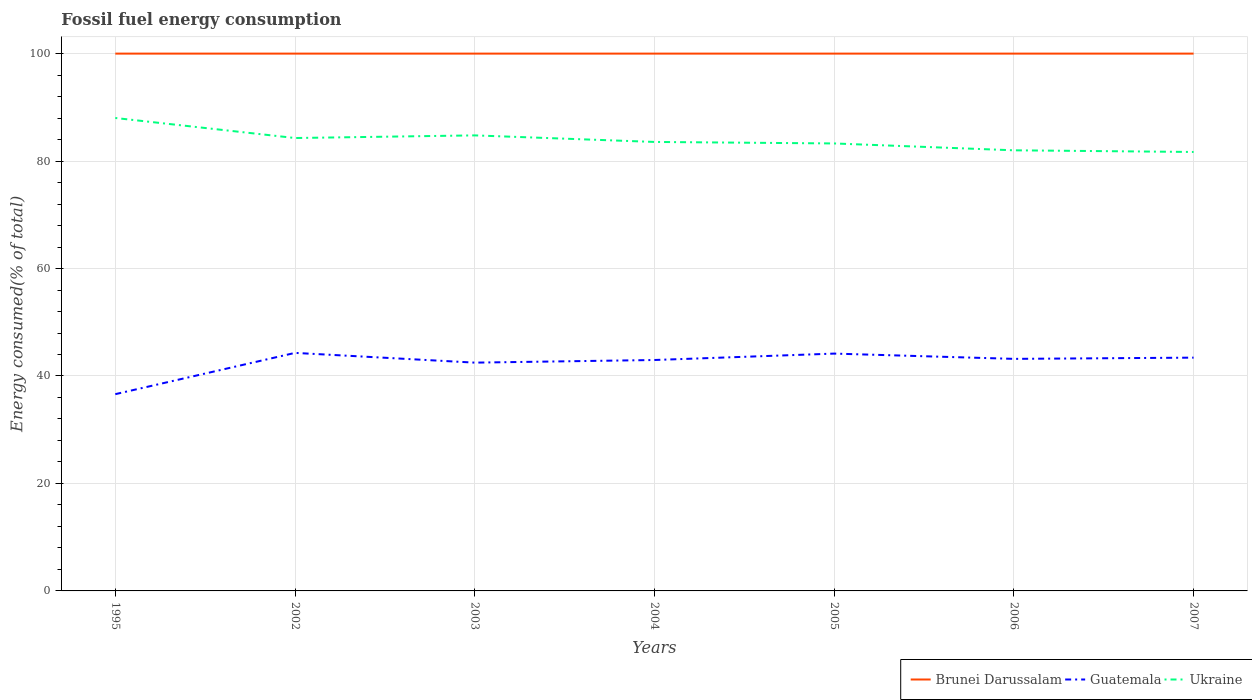How many different coloured lines are there?
Give a very brief answer. 3. Does the line corresponding to Ukraine intersect with the line corresponding to Guatemala?
Provide a short and direct response. No. Is the number of lines equal to the number of legend labels?
Make the answer very short. Yes. Across all years, what is the maximum percentage of energy consumed in Brunei Darussalam?
Your answer should be very brief. 100. In which year was the percentage of energy consumed in Guatemala maximum?
Offer a terse response. 1995. What is the total percentage of energy consumed in Guatemala in the graph?
Your response must be concise. -1.68. What is the difference between the highest and the second highest percentage of energy consumed in Ukraine?
Make the answer very short. 6.33. Is the percentage of energy consumed in Brunei Darussalam strictly greater than the percentage of energy consumed in Ukraine over the years?
Your response must be concise. No. Does the graph contain any zero values?
Your answer should be compact. No. Does the graph contain grids?
Offer a terse response. Yes. What is the title of the graph?
Your answer should be very brief. Fossil fuel energy consumption. Does "Colombia" appear as one of the legend labels in the graph?
Give a very brief answer. No. What is the label or title of the X-axis?
Provide a succinct answer. Years. What is the label or title of the Y-axis?
Provide a succinct answer. Energy consumed(% of total). What is the Energy consumed(% of total) of Guatemala in 1995?
Give a very brief answer. 36.62. What is the Energy consumed(% of total) in Ukraine in 1995?
Your answer should be compact. 88.02. What is the Energy consumed(% of total) of Brunei Darussalam in 2002?
Ensure brevity in your answer.  100. What is the Energy consumed(% of total) in Guatemala in 2002?
Keep it short and to the point. 44.3. What is the Energy consumed(% of total) of Ukraine in 2002?
Your answer should be compact. 84.29. What is the Energy consumed(% of total) in Brunei Darussalam in 2003?
Provide a succinct answer. 100. What is the Energy consumed(% of total) of Guatemala in 2003?
Make the answer very short. 42.49. What is the Energy consumed(% of total) in Ukraine in 2003?
Keep it short and to the point. 84.78. What is the Energy consumed(% of total) of Guatemala in 2004?
Offer a very short reply. 42.98. What is the Energy consumed(% of total) in Ukraine in 2004?
Your response must be concise. 83.56. What is the Energy consumed(% of total) of Brunei Darussalam in 2005?
Make the answer very short. 100. What is the Energy consumed(% of total) of Guatemala in 2005?
Offer a very short reply. 44.17. What is the Energy consumed(% of total) of Ukraine in 2005?
Your answer should be very brief. 83.28. What is the Energy consumed(% of total) of Guatemala in 2006?
Keep it short and to the point. 43.19. What is the Energy consumed(% of total) in Ukraine in 2006?
Provide a succinct answer. 82. What is the Energy consumed(% of total) in Brunei Darussalam in 2007?
Your answer should be compact. 100. What is the Energy consumed(% of total) in Guatemala in 2007?
Give a very brief answer. 43.42. What is the Energy consumed(% of total) of Ukraine in 2007?
Provide a succinct answer. 81.69. Across all years, what is the maximum Energy consumed(% of total) of Guatemala?
Provide a short and direct response. 44.3. Across all years, what is the maximum Energy consumed(% of total) in Ukraine?
Offer a terse response. 88.02. Across all years, what is the minimum Energy consumed(% of total) of Brunei Darussalam?
Your answer should be very brief. 100. Across all years, what is the minimum Energy consumed(% of total) in Guatemala?
Give a very brief answer. 36.62. Across all years, what is the minimum Energy consumed(% of total) of Ukraine?
Make the answer very short. 81.69. What is the total Energy consumed(% of total) in Brunei Darussalam in the graph?
Give a very brief answer. 700. What is the total Energy consumed(% of total) in Guatemala in the graph?
Keep it short and to the point. 297.15. What is the total Energy consumed(% of total) in Ukraine in the graph?
Provide a short and direct response. 587.62. What is the difference between the Energy consumed(% of total) of Brunei Darussalam in 1995 and that in 2002?
Keep it short and to the point. 0. What is the difference between the Energy consumed(% of total) of Guatemala in 1995 and that in 2002?
Ensure brevity in your answer.  -7.68. What is the difference between the Energy consumed(% of total) in Ukraine in 1995 and that in 2002?
Give a very brief answer. 3.73. What is the difference between the Energy consumed(% of total) in Brunei Darussalam in 1995 and that in 2003?
Your answer should be compact. 0. What is the difference between the Energy consumed(% of total) of Guatemala in 1995 and that in 2003?
Your answer should be compact. -5.87. What is the difference between the Energy consumed(% of total) in Ukraine in 1995 and that in 2003?
Give a very brief answer. 3.24. What is the difference between the Energy consumed(% of total) in Guatemala in 1995 and that in 2004?
Offer a terse response. -6.36. What is the difference between the Energy consumed(% of total) in Ukraine in 1995 and that in 2004?
Your answer should be compact. 4.46. What is the difference between the Energy consumed(% of total) of Guatemala in 1995 and that in 2005?
Your response must be concise. -7.55. What is the difference between the Energy consumed(% of total) in Ukraine in 1995 and that in 2005?
Offer a very short reply. 4.74. What is the difference between the Energy consumed(% of total) in Brunei Darussalam in 1995 and that in 2006?
Provide a succinct answer. 0. What is the difference between the Energy consumed(% of total) in Guatemala in 1995 and that in 2006?
Give a very brief answer. -6.57. What is the difference between the Energy consumed(% of total) in Ukraine in 1995 and that in 2006?
Make the answer very short. 6.02. What is the difference between the Energy consumed(% of total) of Brunei Darussalam in 1995 and that in 2007?
Provide a short and direct response. 0. What is the difference between the Energy consumed(% of total) in Guatemala in 1995 and that in 2007?
Ensure brevity in your answer.  -6.8. What is the difference between the Energy consumed(% of total) in Ukraine in 1995 and that in 2007?
Your response must be concise. 6.33. What is the difference between the Energy consumed(% of total) of Brunei Darussalam in 2002 and that in 2003?
Your answer should be very brief. -0. What is the difference between the Energy consumed(% of total) in Guatemala in 2002 and that in 2003?
Your answer should be very brief. 1.81. What is the difference between the Energy consumed(% of total) in Ukraine in 2002 and that in 2003?
Your answer should be compact. -0.49. What is the difference between the Energy consumed(% of total) of Brunei Darussalam in 2002 and that in 2004?
Make the answer very short. -0. What is the difference between the Energy consumed(% of total) in Guatemala in 2002 and that in 2004?
Provide a short and direct response. 1.33. What is the difference between the Energy consumed(% of total) in Ukraine in 2002 and that in 2004?
Provide a short and direct response. 0.73. What is the difference between the Energy consumed(% of total) of Brunei Darussalam in 2002 and that in 2005?
Your answer should be compact. -0. What is the difference between the Energy consumed(% of total) of Guatemala in 2002 and that in 2005?
Provide a short and direct response. 0.13. What is the difference between the Energy consumed(% of total) of Ukraine in 2002 and that in 2005?
Your answer should be very brief. 1.01. What is the difference between the Energy consumed(% of total) of Brunei Darussalam in 2002 and that in 2006?
Make the answer very short. -0. What is the difference between the Energy consumed(% of total) in Guatemala in 2002 and that in 2006?
Provide a short and direct response. 1.11. What is the difference between the Energy consumed(% of total) in Ukraine in 2002 and that in 2006?
Your answer should be compact. 2.29. What is the difference between the Energy consumed(% of total) in Brunei Darussalam in 2002 and that in 2007?
Your response must be concise. -0. What is the difference between the Energy consumed(% of total) in Guatemala in 2002 and that in 2007?
Your answer should be compact. 0.89. What is the difference between the Energy consumed(% of total) in Ukraine in 2002 and that in 2007?
Your response must be concise. 2.6. What is the difference between the Energy consumed(% of total) of Brunei Darussalam in 2003 and that in 2004?
Your answer should be very brief. 0. What is the difference between the Energy consumed(% of total) of Guatemala in 2003 and that in 2004?
Offer a very short reply. -0.49. What is the difference between the Energy consumed(% of total) of Ukraine in 2003 and that in 2004?
Offer a terse response. 1.22. What is the difference between the Energy consumed(% of total) of Brunei Darussalam in 2003 and that in 2005?
Your answer should be compact. 0. What is the difference between the Energy consumed(% of total) in Guatemala in 2003 and that in 2005?
Offer a terse response. -1.68. What is the difference between the Energy consumed(% of total) of Ukraine in 2003 and that in 2005?
Offer a terse response. 1.5. What is the difference between the Energy consumed(% of total) of Guatemala in 2003 and that in 2006?
Provide a succinct answer. -0.7. What is the difference between the Energy consumed(% of total) in Ukraine in 2003 and that in 2006?
Your answer should be very brief. 2.78. What is the difference between the Energy consumed(% of total) in Brunei Darussalam in 2003 and that in 2007?
Your answer should be compact. 0. What is the difference between the Energy consumed(% of total) of Guatemala in 2003 and that in 2007?
Make the answer very short. -0.93. What is the difference between the Energy consumed(% of total) of Ukraine in 2003 and that in 2007?
Your answer should be very brief. 3.09. What is the difference between the Energy consumed(% of total) of Brunei Darussalam in 2004 and that in 2005?
Your answer should be very brief. 0. What is the difference between the Energy consumed(% of total) in Guatemala in 2004 and that in 2005?
Provide a short and direct response. -1.19. What is the difference between the Energy consumed(% of total) of Ukraine in 2004 and that in 2005?
Give a very brief answer. 0.28. What is the difference between the Energy consumed(% of total) in Brunei Darussalam in 2004 and that in 2006?
Offer a terse response. 0. What is the difference between the Energy consumed(% of total) of Guatemala in 2004 and that in 2006?
Provide a succinct answer. -0.21. What is the difference between the Energy consumed(% of total) of Ukraine in 2004 and that in 2006?
Make the answer very short. 1.56. What is the difference between the Energy consumed(% of total) of Brunei Darussalam in 2004 and that in 2007?
Your answer should be compact. 0. What is the difference between the Energy consumed(% of total) of Guatemala in 2004 and that in 2007?
Give a very brief answer. -0.44. What is the difference between the Energy consumed(% of total) in Ukraine in 2004 and that in 2007?
Make the answer very short. 1.87. What is the difference between the Energy consumed(% of total) of Brunei Darussalam in 2005 and that in 2006?
Offer a very short reply. 0. What is the difference between the Energy consumed(% of total) of Guatemala in 2005 and that in 2006?
Give a very brief answer. 0.98. What is the difference between the Energy consumed(% of total) in Ukraine in 2005 and that in 2006?
Give a very brief answer. 1.28. What is the difference between the Energy consumed(% of total) of Brunei Darussalam in 2005 and that in 2007?
Offer a very short reply. 0. What is the difference between the Energy consumed(% of total) in Guatemala in 2005 and that in 2007?
Give a very brief answer. 0.75. What is the difference between the Energy consumed(% of total) of Ukraine in 2005 and that in 2007?
Offer a very short reply. 1.59. What is the difference between the Energy consumed(% of total) of Brunei Darussalam in 2006 and that in 2007?
Your answer should be compact. 0. What is the difference between the Energy consumed(% of total) of Guatemala in 2006 and that in 2007?
Keep it short and to the point. -0.23. What is the difference between the Energy consumed(% of total) of Ukraine in 2006 and that in 2007?
Offer a very short reply. 0.31. What is the difference between the Energy consumed(% of total) in Brunei Darussalam in 1995 and the Energy consumed(% of total) in Guatemala in 2002?
Offer a very short reply. 55.7. What is the difference between the Energy consumed(% of total) in Brunei Darussalam in 1995 and the Energy consumed(% of total) in Ukraine in 2002?
Ensure brevity in your answer.  15.71. What is the difference between the Energy consumed(% of total) of Guatemala in 1995 and the Energy consumed(% of total) of Ukraine in 2002?
Your response must be concise. -47.67. What is the difference between the Energy consumed(% of total) in Brunei Darussalam in 1995 and the Energy consumed(% of total) in Guatemala in 2003?
Offer a very short reply. 57.51. What is the difference between the Energy consumed(% of total) of Brunei Darussalam in 1995 and the Energy consumed(% of total) of Ukraine in 2003?
Your answer should be compact. 15.22. What is the difference between the Energy consumed(% of total) in Guatemala in 1995 and the Energy consumed(% of total) in Ukraine in 2003?
Your answer should be very brief. -48.16. What is the difference between the Energy consumed(% of total) of Brunei Darussalam in 1995 and the Energy consumed(% of total) of Guatemala in 2004?
Give a very brief answer. 57.02. What is the difference between the Energy consumed(% of total) in Brunei Darussalam in 1995 and the Energy consumed(% of total) in Ukraine in 2004?
Give a very brief answer. 16.44. What is the difference between the Energy consumed(% of total) in Guatemala in 1995 and the Energy consumed(% of total) in Ukraine in 2004?
Provide a short and direct response. -46.94. What is the difference between the Energy consumed(% of total) of Brunei Darussalam in 1995 and the Energy consumed(% of total) of Guatemala in 2005?
Your response must be concise. 55.83. What is the difference between the Energy consumed(% of total) of Brunei Darussalam in 1995 and the Energy consumed(% of total) of Ukraine in 2005?
Provide a short and direct response. 16.72. What is the difference between the Energy consumed(% of total) in Guatemala in 1995 and the Energy consumed(% of total) in Ukraine in 2005?
Offer a terse response. -46.66. What is the difference between the Energy consumed(% of total) in Brunei Darussalam in 1995 and the Energy consumed(% of total) in Guatemala in 2006?
Make the answer very short. 56.81. What is the difference between the Energy consumed(% of total) in Brunei Darussalam in 1995 and the Energy consumed(% of total) in Ukraine in 2006?
Offer a terse response. 18. What is the difference between the Energy consumed(% of total) in Guatemala in 1995 and the Energy consumed(% of total) in Ukraine in 2006?
Make the answer very short. -45.38. What is the difference between the Energy consumed(% of total) of Brunei Darussalam in 1995 and the Energy consumed(% of total) of Guatemala in 2007?
Offer a terse response. 56.58. What is the difference between the Energy consumed(% of total) of Brunei Darussalam in 1995 and the Energy consumed(% of total) of Ukraine in 2007?
Ensure brevity in your answer.  18.31. What is the difference between the Energy consumed(% of total) of Guatemala in 1995 and the Energy consumed(% of total) of Ukraine in 2007?
Give a very brief answer. -45.07. What is the difference between the Energy consumed(% of total) in Brunei Darussalam in 2002 and the Energy consumed(% of total) in Guatemala in 2003?
Provide a short and direct response. 57.51. What is the difference between the Energy consumed(% of total) in Brunei Darussalam in 2002 and the Energy consumed(% of total) in Ukraine in 2003?
Your answer should be very brief. 15.22. What is the difference between the Energy consumed(% of total) of Guatemala in 2002 and the Energy consumed(% of total) of Ukraine in 2003?
Keep it short and to the point. -40.48. What is the difference between the Energy consumed(% of total) of Brunei Darussalam in 2002 and the Energy consumed(% of total) of Guatemala in 2004?
Provide a succinct answer. 57.02. What is the difference between the Energy consumed(% of total) of Brunei Darussalam in 2002 and the Energy consumed(% of total) of Ukraine in 2004?
Your answer should be compact. 16.44. What is the difference between the Energy consumed(% of total) of Guatemala in 2002 and the Energy consumed(% of total) of Ukraine in 2004?
Your answer should be very brief. -39.26. What is the difference between the Energy consumed(% of total) in Brunei Darussalam in 2002 and the Energy consumed(% of total) in Guatemala in 2005?
Your response must be concise. 55.83. What is the difference between the Energy consumed(% of total) in Brunei Darussalam in 2002 and the Energy consumed(% of total) in Ukraine in 2005?
Offer a terse response. 16.72. What is the difference between the Energy consumed(% of total) in Guatemala in 2002 and the Energy consumed(% of total) in Ukraine in 2005?
Make the answer very short. -38.98. What is the difference between the Energy consumed(% of total) of Brunei Darussalam in 2002 and the Energy consumed(% of total) of Guatemala in 2006?
Keep it short and to the point. 56.81. What is the difference between the Energy consumed(% of total) of Brunei Darussalam in 2002 and the Energy consumed(% of total) of Ukraine in 2006?
Your answer should be compact. 18. What is the difference between the Energy consumed(% of total) of Guatemala in 2002 and the Energy consumed(% of total) of Ukraine in 2006?
Your response must be concise. -37.7. What is the difference between the Energy consumed(% of total) in Brunei Darussalam in 2002 and the Energy consumed(% of total) in Guatemala in 2007?
Keep it short and to the point. 56.58. What is the difference between the Energy consumed(% of total) in Brunei Darussalam in 2002 and the Energy consumed(% of total) in Ukraine in 2007?
Offer a very short reply. 18.31. What is the difference between the Energy consumed(% of total) of Guatemala in 2002 and the Energy consumed(% of total) of Ukraine in 2007?
Your answer should be very brief. -37.39. What is the difference between the Energy consumed(% of total) of Brunei Darussalam in 2003 and the Energy consumed(% of total) of Guatemala in 2004?
Give a very brief answer. 57.02. What is the difference between the Energy consumed(% of total) of Brunei Darussalam in 2003 and the Energy consumed(% of total) of Ukraine in 2004?
Your answer should be compact. 16.44. What is the difference between the Energy consumed(% of total) of Guatemala in 2003 and the Energy consumed(% of total) of Ukraine in 2004?
Make the answer very short. -41.07. What is the difference between the Energy consumed(% of total) in Brunei Darussalam in 2003 and the Energy consumed(% of total) in Guatemala in 2005?
Ensure brevity in your answer.  55.83. What is the difference between the Energy consumed(% of total) in Brunei Darussalam in 2003 and the Energy consumed(% of total) in Ukraine in 2005?
Offer a terse response. 16.72. What is the difference between the Energy consumed(% of total) of Guatemala in 2003 and the Energy consumed(% of total) of Ukraine in 2005?
Your answer should be compact. -40.79. What is the difference between the Energy consumed(% of total) in Brunei Darussalam in 2003 and the Energy consumed(% of total) in Guatemala in 2006?
Make the answer very short. 56.81. What is the difference between the Energy consumed(% of total) of Brunei Darussalam in 2003 and the Energy consumed(% of total) of Ukraine in 2006?
Offer a very short reply. 18. What is the difference between the Energy consumed(% of total) of Guatemala in 2003 and the Energy consumed(% of total) of Ukraine in 2006?
Your response must be concise. -39.52. What is the difference between the Energy consumed(% of total) in Brunei Darussalam in 2003 and the Energy consumed(% of total) in Guatemala in 2007?
Provide a short and direct response. 56.58. What is the difference between the Energy consumed(% of total) of Brunei Darussalam in 2003 and the Energy consumed(% of total) of Ukraine in 2007?
Ensure brevity in your answer.  18.31. What is the difference between the Energy consumed(% of total) in Guatemala in 2003 and the Energy consumed(% of total) in Ukraine in 2007?
Your answer should be very brief. -39.21. What is the difference between the Energy consumed(% of total) of Brunei Darussalam in 2004 and the Energy consumed(% of total) of Guatemala in 2005?
Offer a terse response. 55.83. What is the difference between the Energy consumed(% of total) of Brunei Darussalam in 2004 and the Energy consumed(% of total) of Ukraine in 2005?
Provide a succinct answer. 16.72. What is the difference between the Energy consumed(% of total) of Guatemala in 2004 and the Energy consumed(% of total) of Ukraine in 2005?
Offer a very short reply. -40.3. What is the difference between the Energy consumed(% of total) in Brunei Darussalam in 2004 and the Energy consumed(% of total) in Guatemala in 2006?
Offer a very short reply. 56.81. What is the difference between the Energy consumed(% of total) of Brunei Darussalam in 2004 and the Energy consumed(% of total) of Ukraine in 2006?
Make the answer very short. 18. What is the difference between the Energy consumed(% of total) in Guatemala in 2004 and the Energy consumed(% of total) in Ukraine in 2006?
Your answer should be very brief. -39.03. What is the difference between the Energy consumed(% of total) of Brunei Darussalam in 2004 and the Energy consumed(% of total) of Guatemala in 2007?
Provide a short and direct response. 56.58. What is the difference between the Energy consumed(% of total) in Brunei Darussalam in 2004 and the Energy consumed(% of total) in Ukraine in 2007?
Offer a very short reply. 18.31. What is the difference between the Energy consumed(% of total) in Guatemala in 2004 and the Energy consumed(% of total) in Ukraine in 2007?
Provide a short and direct response. -38.72. What is the difference between the Energy consumed(% of total) in Brunei Darussalam in 2005 and the Energy consumed(% of total) in Guatemala in 2006?
Provide a short and direct response. 56.81. What is the difference between the Energy consumed(% of total) of Brunei Darussalam in 2005 and the Energy consumed(% of total) of Ukraine in 2006?
Your response must be concise. 18. What is the difference between the Energy consumed(% of total) in Guatemala in 2005 and the Energy consumed(% of total) in Ukraine in 2006?
Give a very brief answer. -37.83. What is the difference between the Energy consumed(% of total) in Brunei Darussalam in 2005 and the Energy consumed(% of total) in Guatemala in 2007?
Give a very brief answer. 56.58. What is the difference between the Energy consumed(% of total) in Brunei Darussalam in 2005 and the Energy consumed(% of total) in Ukraine in 2007?
Give a very brief answer. 18.31. What is the difference between the Energy consumed(% of total) of Guatemala in 2005 and the Energy consumed(% of total) of Ukraine in 2007?
Offer a very short reply. -37.52. What is the difference between the Energy consumed(% of total) in Brunei Darussalam in 2006 and the Energy consumed(% of total) in Guatemala in 2007?
Provide a succinct answer. 56.58. What is the difference between the Energy consumed(% of total) of Brunei Darussalam in 2006 and the Energy consumed(% of total) of Ukraine in 2007?
Your answer should be compact. 18.31. What is the difference between the Energy consumed(% of total) in Guatemala in 2006 and the Energy consumed(% of total) in Ukraine in 2007?
Make the answer very short. -38.51. What is the average Energy consumed(% of total) in Guatemala per year?
Ensure brevity in your answer.  42.45. What is the average Energy consumed(% of total) of Ukraine per year?
Ensure brevity in your answer.  83.95. In the year 1995, what is the difference between the Energy consumed(% of total) of Brunei Darussalam and Energy consumed(% of total) of Guatemala?
Keep it short and to the point. 63.38. In the year 1995, what is the difference between the Energy consumed(% of total) in Brunei Darussalam and Energy consumed(% of total) in Ukraine?
Your answer should be very brief. 11.98. In the year 1995, what is the difference between the Energy consumed(% of total) in Guatemala and Energy consumed(% of total) in Ukraine?
Offer a terse response. -51.4. In the year 2002, what is the difference between the Energy consumed(% of total) of Brunei Darussalam and Energy consumed(% of total) of Guatemala?
Your answer should be very brief. 55.7. In the year 2002, what is the difference between the Energy consumed(% of total) of Brunei Darussalam and Energy consumed(% of total) of Ukraine?
Ensure brevity in your answer.  15.71. In the year 2002, what is the difference between the Energy consumed(% of total) in Guatemala and Energy consumed(% of total) in Ukraine?
Ensure brevity in your answer.  -39.99. In the year 2003, what is the difference between the Energy consumed(% of total) in Brunei Darussalam and Energy consumed(% of total) in Guatemala?
Your response must be concise. 57.51. In the year 2003, what is the difference between the Energy consumed(% of total) of Brunei Darussalam and Energy consumed(% of total) of Ukraine?
Keep it short and to the point. 15.22. In the year 2003, what is the difference between the Energy consumed(% of total) in Guatemala and Energy consumed(% of total) in Ukraine?
Provide a short and direct response. -42.29. In the year 2004, what is the difference between the Energy consumed(% of total) in Brunei Darussalam and Energy consumed(% of total) in Guatemala?
Keep it short and to the point. 57.02. In the year 2004, what is the difference between the Energy consumed(% of total) in Brunei Darussalam and Energy consumed(% of total) in Ukraine?
Your response must be concise. 16.44. In the year 2004, what is the difference between the Energy consumed(% of total) in Guatemala and Energy consumed(% of total) in Ukraine?
Make the answer very short. -40.58. In the year 2005, what is the difference between the Energy consumed(% of total) of Brunei Darussalam and Energy consumed(% of total) of Guatemala?
Your response must be concise. 55.83. In the year 2005, what is the difference between the Energy consumed(% of total) in Brunei Darussalam and Energy consumed(% of total) in Ukraine?
Your response must be concise. 16.72. In the year 2005, what is the difference between the Energy consumed(% of total) of Guatemala and Energy consumed(% of total) of Ukraine?
Offer a terse response. -39.11. In the year 2006, what is the difference between the Energy consumed(% of total) of Brunei Darussalam and Energy consumed(% of total) of Guatemala?
Ensure brevity in your answer.  56.81. In the year 2006, what is the difference between the Energy consumed(% of total) of Brunei Darussalam and Energy consumed(% of total) of Ukraine?
Offer a very short reply. 18. In the year 2006, what is the difference between the Energy consumed(% of total) in Guatemala and Energy consumed(% of total) in Ukraine?
Provide a succinct answer. -38.81. In the year 2007, what is the difference between the Energy consumed(% of total) in Brunei Darussalam and Energy consumed(% of total) in Guatemala?
Make the answer very short. 56.58. In the year 2007, what is the difference between the Energy consumed(% of total) of Brunei Darussalam and Energy consumed(% of total) of Ukraine?
Your answer should be very brief. 18.31. In the year 2007, what is the difference between the Energy consumed(% of total) of Guatemala and Energy consumed(% of total) of Ukraine?
Keep it short and to the point. -38.28. What is the ratio of the Energy consumed(% of total) in Guatemala in 1995 to that in 2002?
Offer a terse response. 0.83. What is the ratio of the Energy consumed(% of total) in Ukraine in 1995 to that in 2002?
Your response must be concise. 1.04. What is the ratio of the Energy consumed(% of total) of Guatemala in 1995 to that in 2003?
Ensure brevity in your answer.  0.86. What is the ratio of the Energy consumed(% of total) in Ukraine in 1995 to that in 2003?
Offer a very short reply. 1.04. What is the ratio of the Energy consumed(% of total) in Brunei Darussalam in 1995 to that in 2004?
Offer a very short reply. 1. What is the ratio of the Energy consumed(% of total) of Guatemala in 1995 to that in 2004?
Keep it short and to the point. 0.85. What is the ratio of the Energy consumed(% of total) in Ukraine in 1995 to that in 2004?
Provide a succinct answer. 1.05. What is the ratio of the Energy consumed(% of total) of Brunei Darussalam in 1995 to that in 2005?
Give a very brief answer. 1. What is the ratio of the Energy consumed(% of total) of Guatemala in 1995 to that in 2005?
Make the answer very short. 0.83. What is the ratio of the Energy consumed(% of total) of Ukraine in 1995 to that in 2005?
Give a very brief answer. 1.06. What is the ratio of the Energy consumed(% of total) of Brunei Darussalam in 1995 to that in 2006?
Ensure brevity in your answer.  1. What is the ratio of the Energy consumed(% of total) in Guatemala in 1995 to that in 2006?
Provide a succinct answer. 0.85. What is the ratio of the Energy consumed(% of total) in Ukraine in 1995 to that in 2006?
Provide a short and direct response. 1.07. What is the ratio of the Energy consumed(% of total) of Brunei Darussalam in 1995 to that in 2007?
Offer a terse response. 1. What is the ratio of the Energy consumed(% of total) in Guatemala in 1995 to that in 2007?
Keep it short and to the point. 0.84. What is the ratio of the Energy consumed(% of total) in Ukraine in 1995 to that in 2007?
Offer a very short reply. 1.08. What is the ratio of the Energy consumed(% of total) in Guatemala in 2002 to that in 2003?
Offer a very short reply. 1.04. What is the ratio of the Energy consumed(% of total) of Brunei Darussalam in 2002 to that in 2004?
Your answer should be compact. 1. What is the ratio of the Energy consumed(% of total) of Guatemala in 2002 to that in 2004?
Provide a short and direct response. 1.03. What is the ratio of the Energy consumed(% of total) of Ukraine in 2002 to that in 2004?
Provide a succinct answer. 1.01. What is the ratio of the Energy consumed(% of total) of Brunei Darussalam in 2002 to that in 2005?
Make the answer very short. 1. What is the ratio of the Energy consumed(% of total) in Ukraine in 2002 to that in 2005?
Make the answer very short. 1.01. What is the ratio of the Energy consumed(% of total) in Brunei Darussalam in 2002 to that in 2006?
Your response must be concise. 1. What is the ratio of the Energy consumed(% of total) in Guatemala in 2002 to that in 2006?
Provide a short and direct response. 1.03. What is the ratio of the Energy consumed(% of total) of Ukraine in 2002 to that in 2006?
Your answer should be compact. 1.03. What is the ratio of the Energy consumed(% of total) of Guatemala in 2002 to that in 2007?
Your response must be concise. 1.02. What is the ratio of the Energy consumed(% of total) of Ukraine in 2002 to that in 2007?
Ensure brevity in your answer.  1.03. What is the ratio of the Energy consumed(% of total) of Guatemala in 2003 to that in 2004?
Provide a short and direct response. 0.99. What is the ratio of the Energy consumed(% of total) of Ukraine in 2003 to that in 2004?
Make the answer very short. 1.01. What is the ratio of the Energy consumed(% of total) in Guatemala in 2003 to that in 2005?
Offer a very short reply. 0.96. What is the ratio of the Energy consumed(% of total) in Ukraine in 2003 to that in 2005?
Your answer should be compact. 1.02. What is the ratio of the Energy consumed(% of total) of Brunei Darussalam in 2003 to that in 2006?
Make the answer very short. 1. What is the ratio of the Energy consumed(% of total) in Guatemala in 2003 to that in 2006?
Make the answer very short. 0.98. What is the ratio of the Energy consumed(% of total) in Ukraine in 2003 to that in 2006?
Provide a short and direct response. 1.03. What is the ratio of the Energy consumed(% of total) of Guatemala in 2003 to that in 2007?
Provide a succinct answer. 0.98. What is the ratio of the Energy consumed(% of total) in Ukraine in 2003 to that in 2007?
Ensure brevity in your answer.  1.04. What is the ratio of the Energy consumed(% of total) of Brunei Darussalam in 2004 to that in 2005?
Offer a terse response. 1. What is the ratio of the Energy consumed(% of total) of Guatemala in 2004 to that in 2005?
Give a very brief answer. 0.97. What is the ratio of the Energy consumed(% of total) in Ukraine in 2004 to that in 2005?
Provide a succinct answer. 1. What is the ratio of the Energy consumed(% of total) of Ukraine in 2004 to that in 2006?
Give a very brief answer. 1.02. What is the ratio of the Energy consumed(% of total) in Ukraine in 2004 to that in 2007?
Your answer should be very brief. 1.02. What is the ratio of the Energy consumed(% of total) in Guatemala in 2005 to that in 2006?
Ensure brevity in your answer.  1.02. What is the ratio of the Energy consumed(% of total) in Ukraine in 2005 to that in 2006?
Provide a short and direct response. 1.02. What is the ratio of the Energy consumed(% of total) in Brunei Darussalam in 2005 to that in 2007?
Ensure brevity in your answer.  1. What is the ratio of the Energy consumed(% of total) in Guatemala in 2005 to that in 2007?
Give a very brief answer. 1.02. What is the ratio of the Energy consumed(% of total) in Ukraine in 2005 to that in 2007?
Keep it short and to the point. 1.02. What is the difference between the highest and the second highest Energy consumed(% of total) in Guatemala?
Provide a short and direct response. 0.13. What is the difference between the highest and the second highest Energy consumed(% of total) in Ukraine?
Ensure brevity in your answer.  3.24. What is the difference between the highest and the lowest Energy consumed(% of total) of Brunei Darussalam?
Offer a terse response. 0. What is the difference between the highest and the lowest Energy consumed(% of total) of Guatemala?
Give a very brief answer. 7.68. What is the difference between the highest and the lowest Energy consumed(% of total) of Ukraine?
Your answer should be very brief. 6.33. 